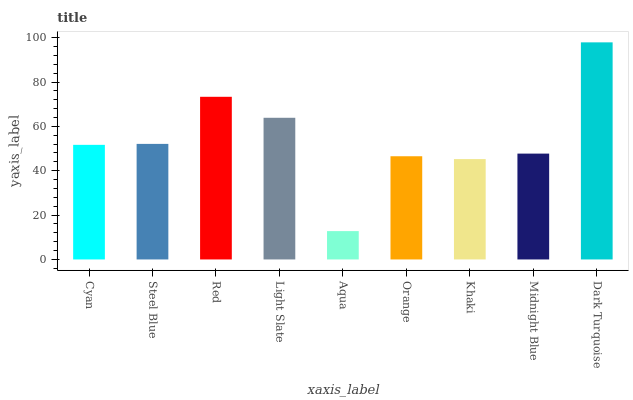Is Aqua the minimum?
Answer yes or no. Yes. Is Dark Turquoise the maximum?
Answer yes or no. Yes. Is Steel Blue the minimum?
Answer yes or no. No. Is Steel Blue the maximum?
Answer yes or no. No. Is Steel Blue greater than Cyan?
Answer yes or no. Yes. Is Cyan less than Steel Blue?
Answer yes or no. Yes. Is Cyan greater than Steel Blue?
Answer yes or no. No. Is Steel Blue less than Cyan?
Answer yes or no. No. Is Cyan the high median?
Answer yes or no. Yes. Is Cyan the low median?
Answer yes or no. Yes. Is Aqua the high median?
Answer yes or no. No. Is Aqua the low median?
Answer yes or no. No. 